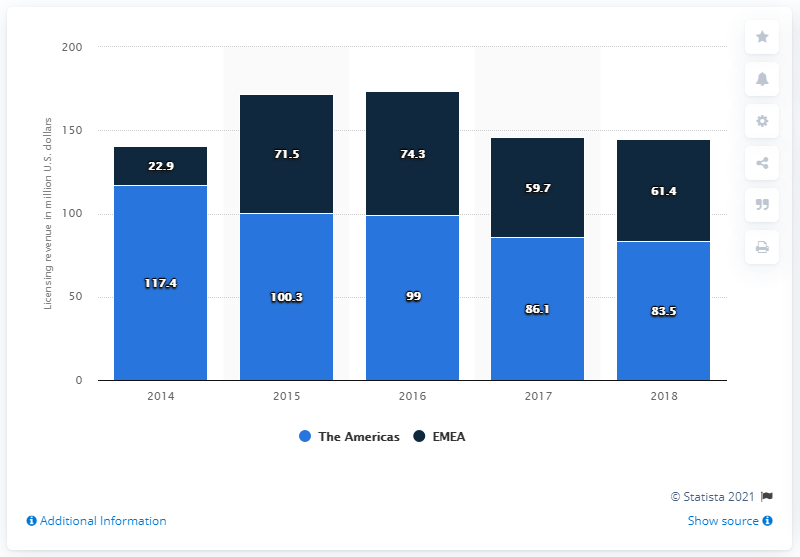Outline some significant characteristics in this image. In 2018, the revenue of Michael Kors' European, Middle Eastern, and African (EMEA) region was 61.4 million dollars. 